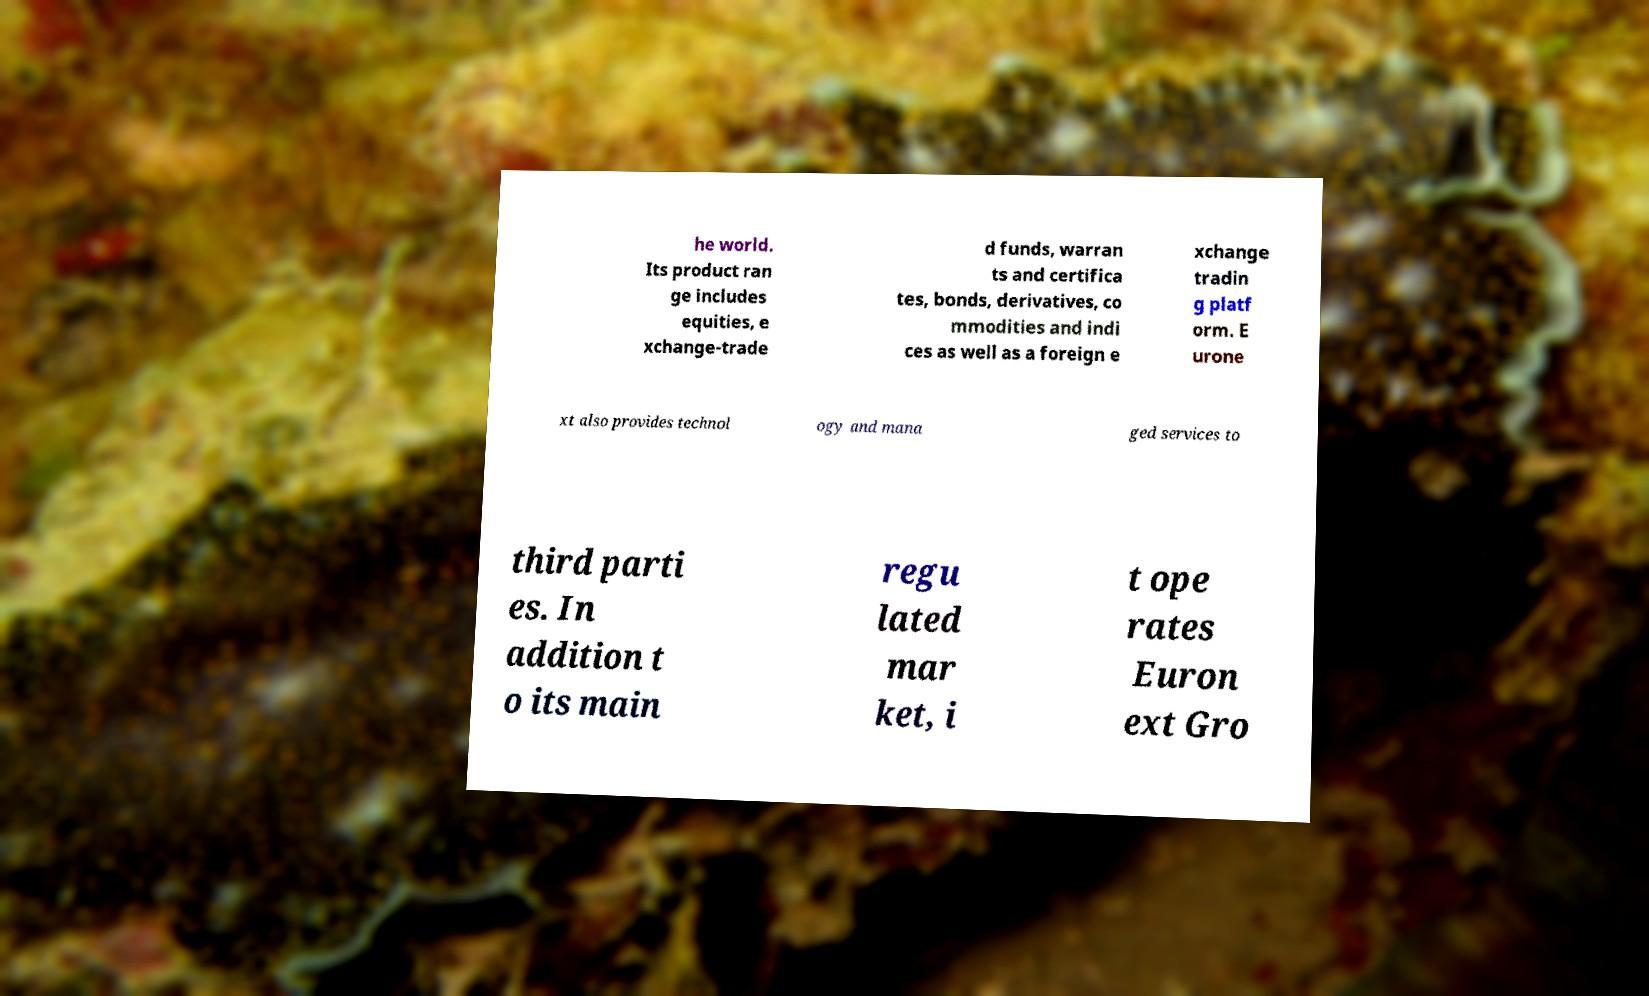Please read and relay the text visible in this image. What does it say? he world. Its product ran ge includes equities, e xchange-trade d funds, warran ts and certifica tes, bonds, derivatives, co mmodities and indi ces as well as a foreign e xchange tradin g platf orm. E urone xt also provides technol ogy and mana ged services to third parti es. In addition t o its main regu lated mar ket, i t ope rates Euron ext Gro 